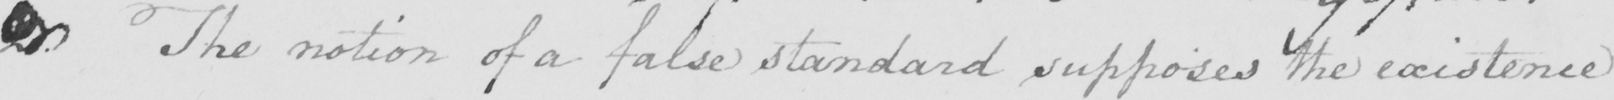Can you read and transcribe this handwriting? <gap/> The notion of a false standard supposes the existence 